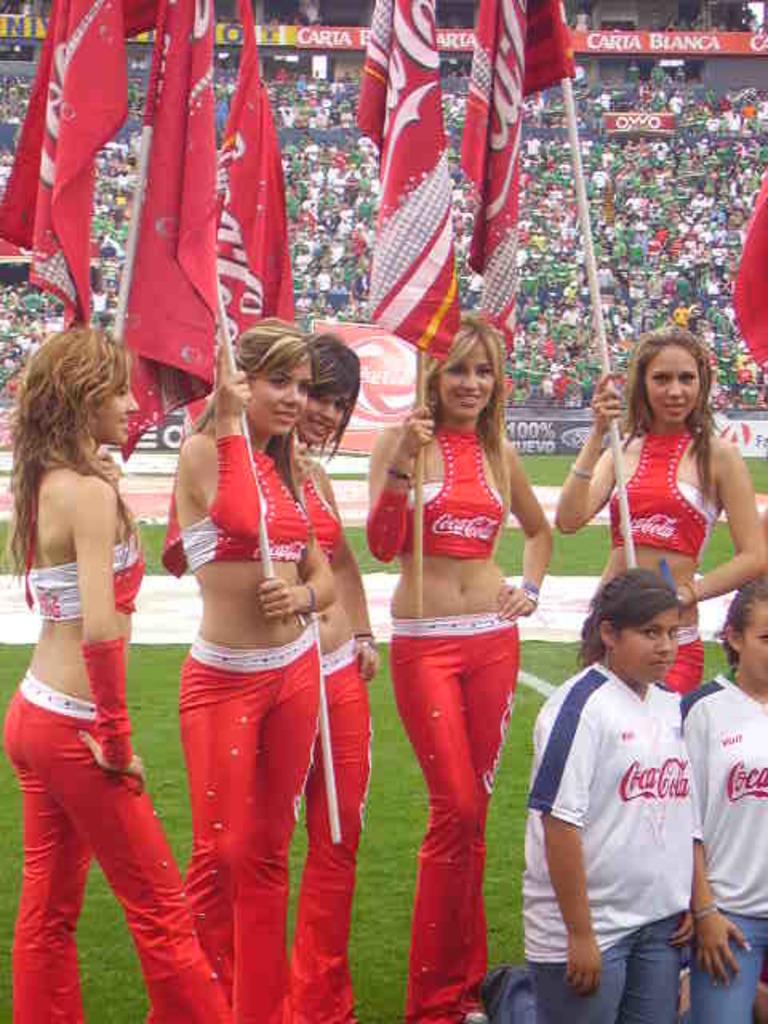What company are these cheerleaders sponsoring?
Give a very brief answer. Coca cola. What is on the red sign behind the girls?
Your answer should be very brief. Unanswerable. 